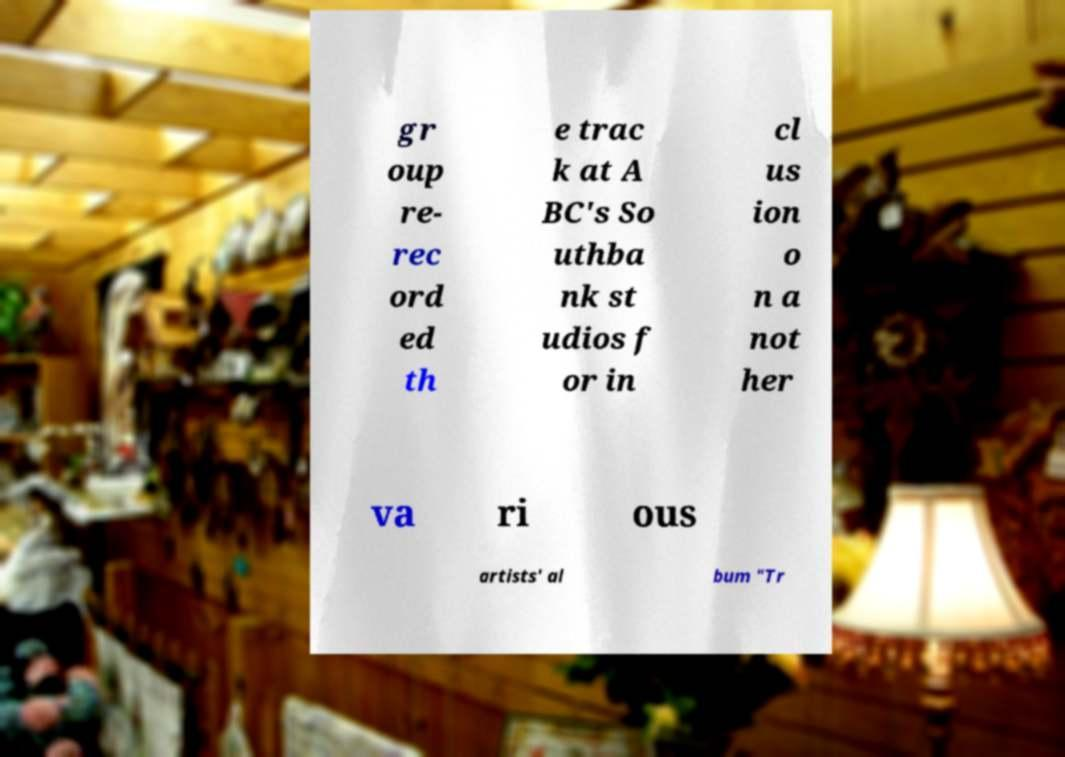Can you read and provide the text displayed in the image?This photo seems to have some interesting text. Can you extract and type it out for me? gr oup re- rec ord ed th e trac k at A BC's So uthba nk st udios f or in cl us ion o n a not her va ri ous artists' al bum "Tr 